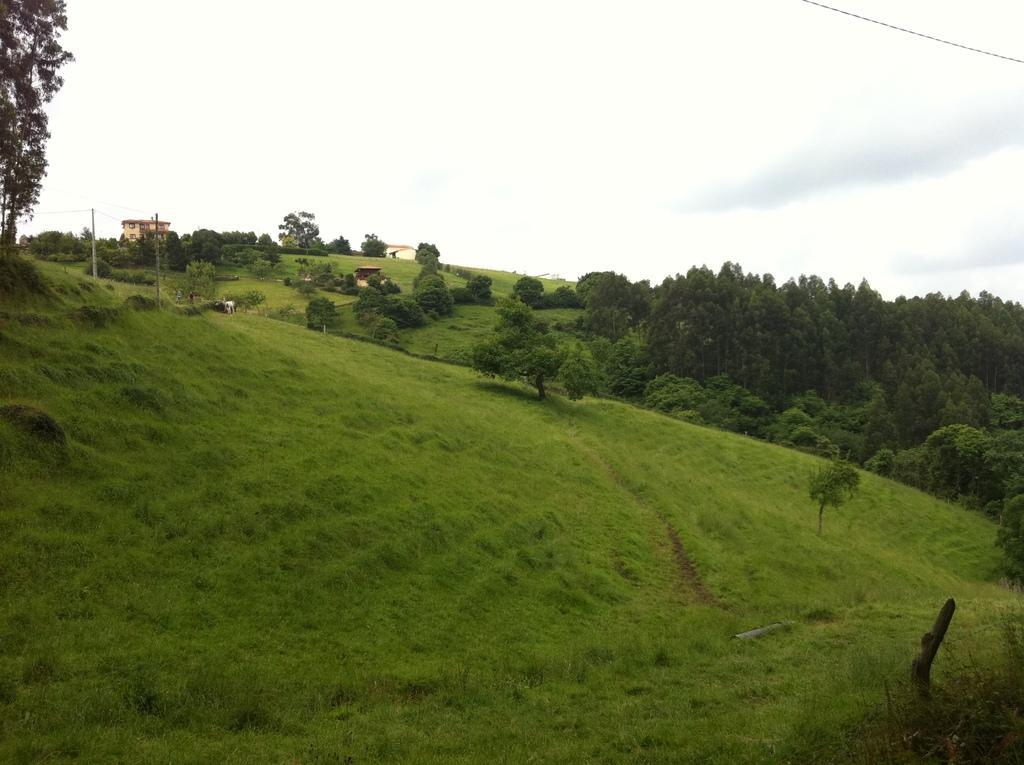Can you describe this image briefly? In this image there is a field and there are trees in the background there are houses and a cloudy sky. 